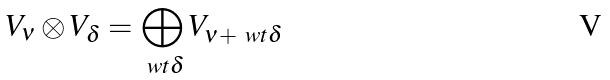Convert formula to latex. <formula><loc_0><loc_0><loc_500><loc_500>V _ { \nu } \otimes V _ { \delta } = \bigoplus _ { \ w t \delta } V _ { \nu + \ w t \delta }</formula> 